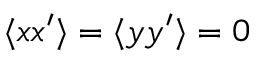Convert formula to latex. <formula><loc_0><loc_0><loc_500><loc_500>\langle { x x ^ { \prime } } \rangle = \langle { y y ^ { \prime } } \rangle = 0</formula> 